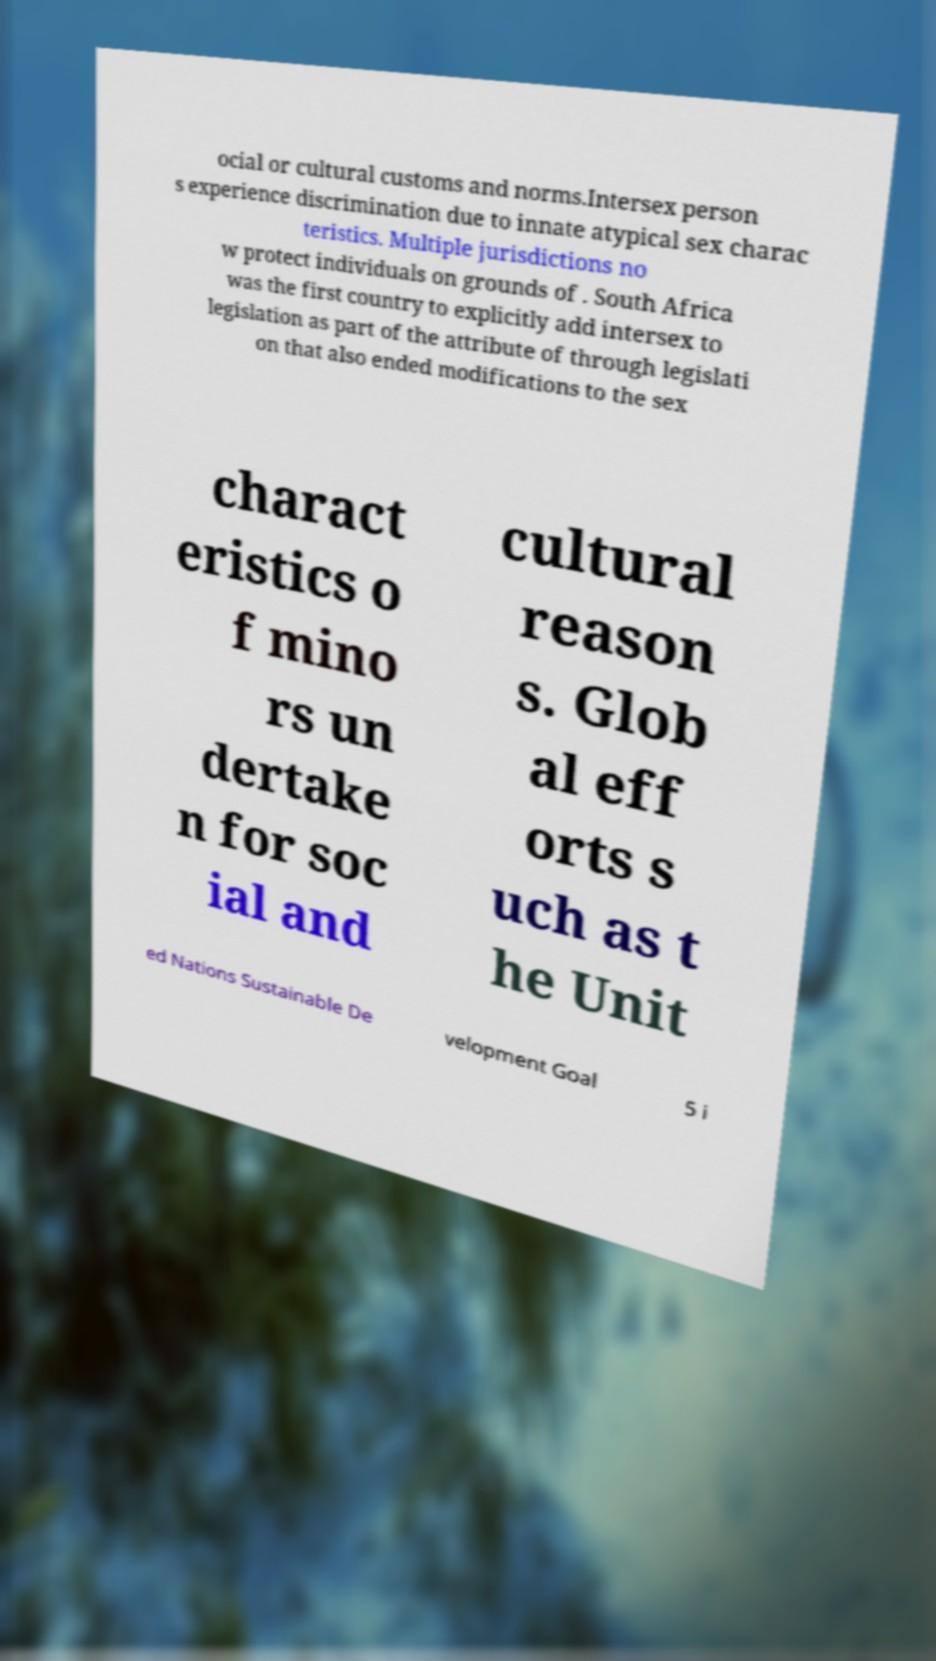There's text embedded in this image that I need extracted. Can you transcribe it verbatim? ocial or cultural customs and norms.Intersex person s experience discrimination due to innate atypical sex charac teristics. Multiple jurisdictions no w protect individuals on grounds of . South Africa was the first country to explicitly add intersex to legislation as part of the attribute of through legislati on that also ended modifications to the sex charact eristics o f mino rs un dertake n for soc ial and cultural reason s. Glob al eff orts s uch as t he Unit ed Nations Sustainable De velopment Goal 5 i 